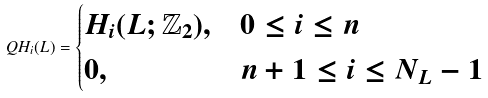<formula> <loc_0><loc_0><loc_500><loc_500>Q H _ { i } ( L ) = \begin{cases} H _ { i } ( L ; \mathbb { Z } _ { 2 } ) , & 0 \leq i \leq n \\ 0 , & n + 1 \leq i \leq N _ { L } - 1 \end{cases}</formula> 